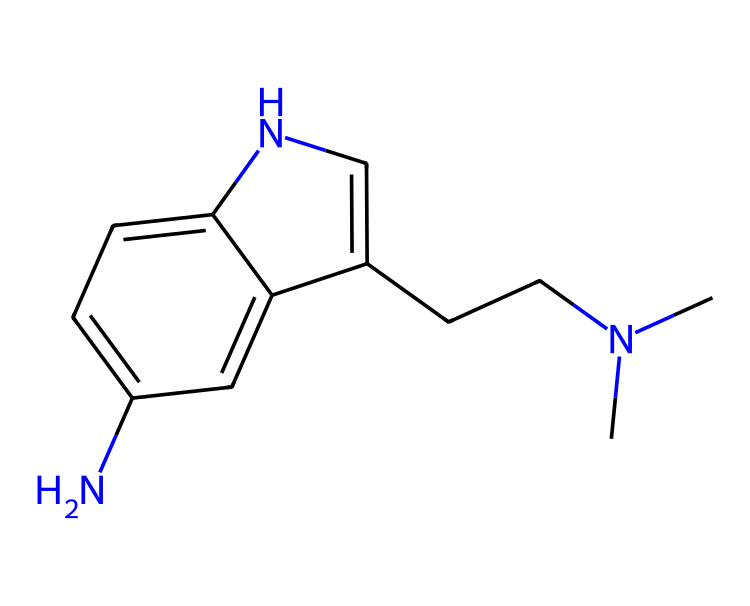How many nitrogen atoms are in the structure? The SMILES representation contains the characters 'N' that denote nitrogen atoms. By scanning the structure, we can identify two instances of 'N', indicating there are two nitrogen atoms present.
Answer: two What is the molecular formula of the compound represented by the SMILES? To determine the molecular formula, we account for the number of each type of atom present in the structure as indicated by the SMILES. Counting carefully, the structure contains 11 carbons (C), 15 hydrogens (H), 2 nitrogens (N), and 1 additional component likely representing a double bond or ring. Thus, the empirical formula is C11H15N2.
Answer: C11H15N2 What type of functional groups can be identified in this molecule? By examining the SMILES structure, we notice the presence of an amine group - represented by the nitrogen atoms - and the aromatic ring structure indicated by the 'C1=CC=C2' portion, which implies that there are benzene-like characteristics. Therefore, the functional groups include amine and aromatic.
Answer: amine and aromatic How does this structure relate to mood regulation? The structure corresponds to serotonin, a well-known neurotransmitter that plays a significant role in regulating mood, anxiety, and overall emotional response in the human brain. The presence of specific nitrogen atoms is crucial for its neurotransmitter properties, facilitating interaction with serotonin receptors.
Answer: serotonin What is the key feature that indicates this chemical's classification as a neurotransmitter? The key feature that indicates this compound functions as a neurotransmitter is the presence of amine groups (nitrogen) that enable it to interact with various receptors in the synapses of neurons. This allows it to transmit signals between nerve cells.
Answer: amine groups What type of isomerism does this molecule exhibit? The structure likely exhibits geometric isomerism due to the presence of double bonds and ring structures that allow for cis and trans configurations in its arrangement. This can affect its function as a neurotransmitter compared to other isomers.
Answer: geometric isomerism 